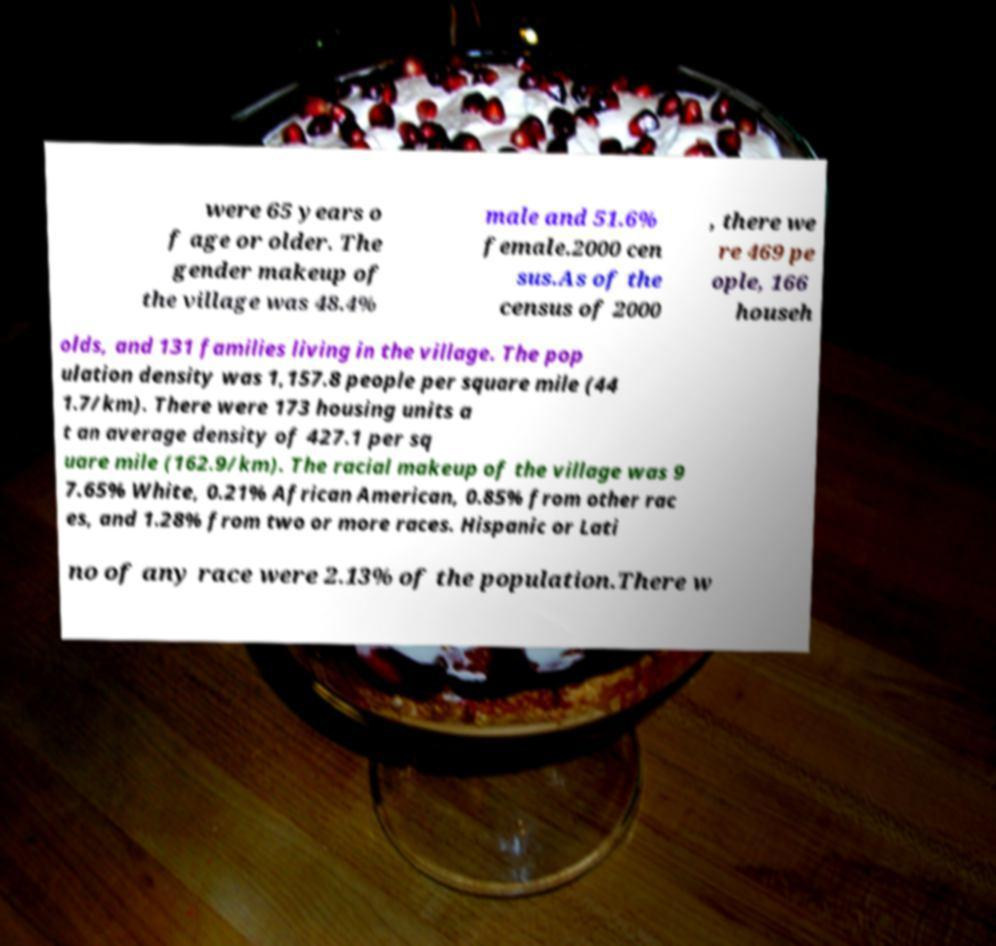Could you extract and type out the text from this image? were 65 years o f age or older. The gender makeup of the village was 48.4% male and 51.6% female.2000 cen sus.As of the census of 2000 , there we re 469 pe ople, 166 househ olds, and 131 families living in the village. The pop ulation density was 1,157.8 people per square mile (44 1.7/km). There were 173 housing units a t an average density of 427.1 per sq uare mile (162.9/km). The racial makeup of the village was 9 7.65% White, 0.21% African American, 0.85% from other rac es, and 1.28% from two or more races. Hispanic or Lati no of any race were 2.13% of the population.There w 